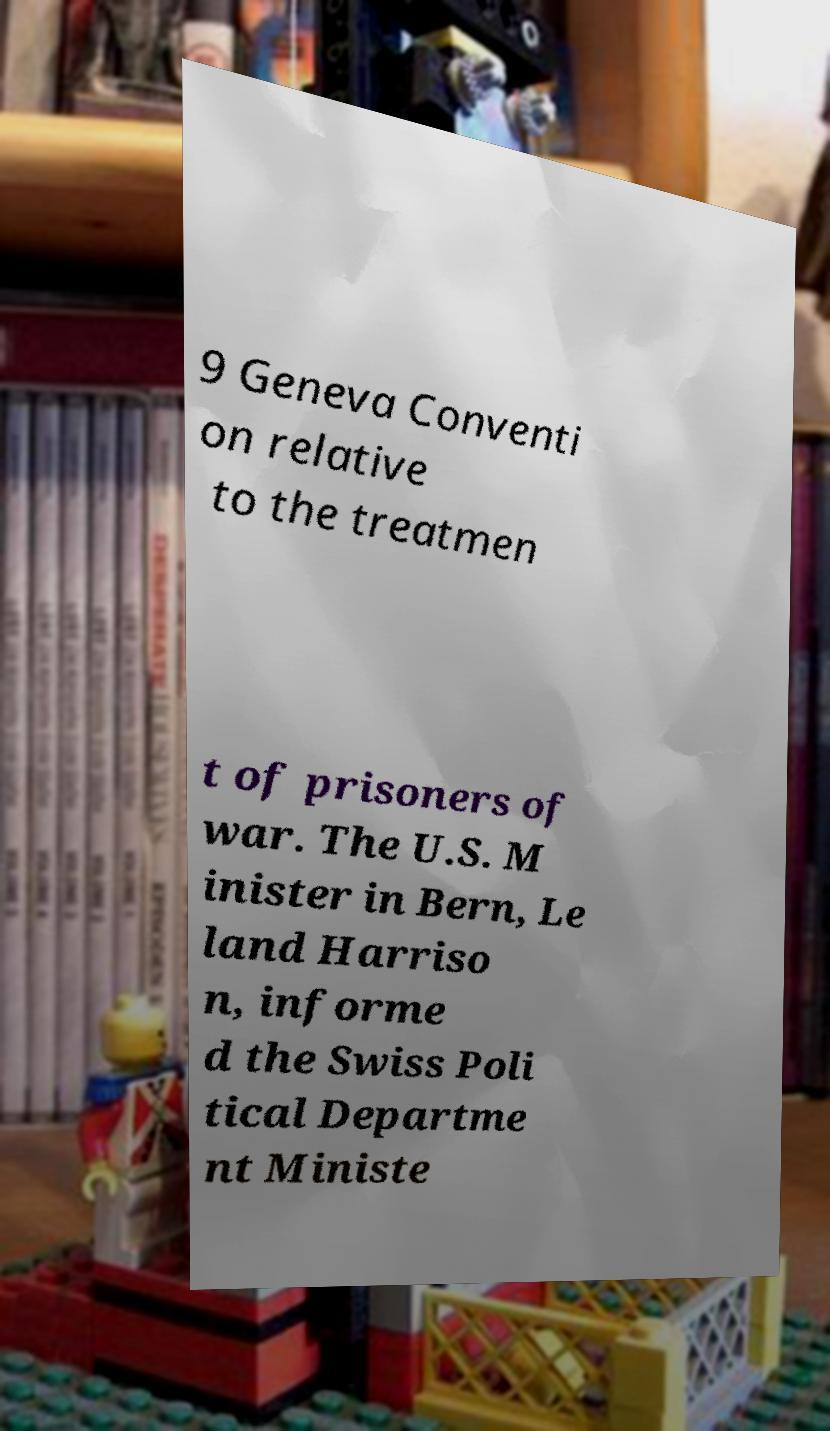I need the written content from this picture converted into text. Can you do that? 9 Geneva Conventi on relative to the treatmen t of prisoners of war. The U.S. M inister in Bern, Le land Harriso n, informe d the Swiss Poli tical Departme nt Ministe 